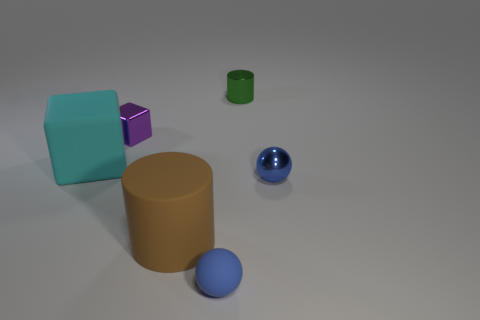What can you tell about the textures of the different objects? The blue sphere and the metal cylinder have reflective, smooth surfaces, while the cube and the smaller objects have matte surfaces with less shine, suggesting a rougher texture. Do the objects in the image serve a purpose? The image seems to be a 3D render or a setup for a visual experiment. The objects don't seem to have a specific functional purpose but are likely used to demonstrate concepts like geometry, reflection, or color. 